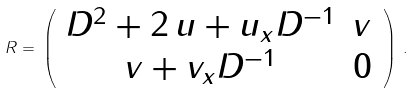Convert formula to latex. <formula><loc_0><loc_0><loc_500><loc_500>R = \, \left ( \begin{array} { c c } D ^ { 2 } + 2 \, u + u _ { x } D ^ { - 1 } & v \\ v + v _ { x } D ^ { - 1 } & 0 \end{array} \, \right ) \, .</formula> 